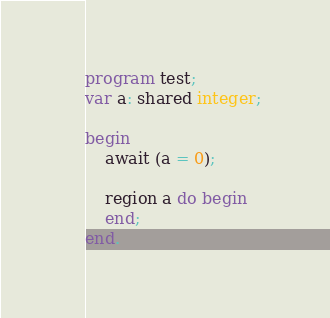Convert code to text. <code><loc_0><loc_0><loc_500><loc_500><_Pascal_>program test;
var a: shared integer;
	
begin
	await (a = 0);
	
	region a do begin 
	end;
end.</code> 